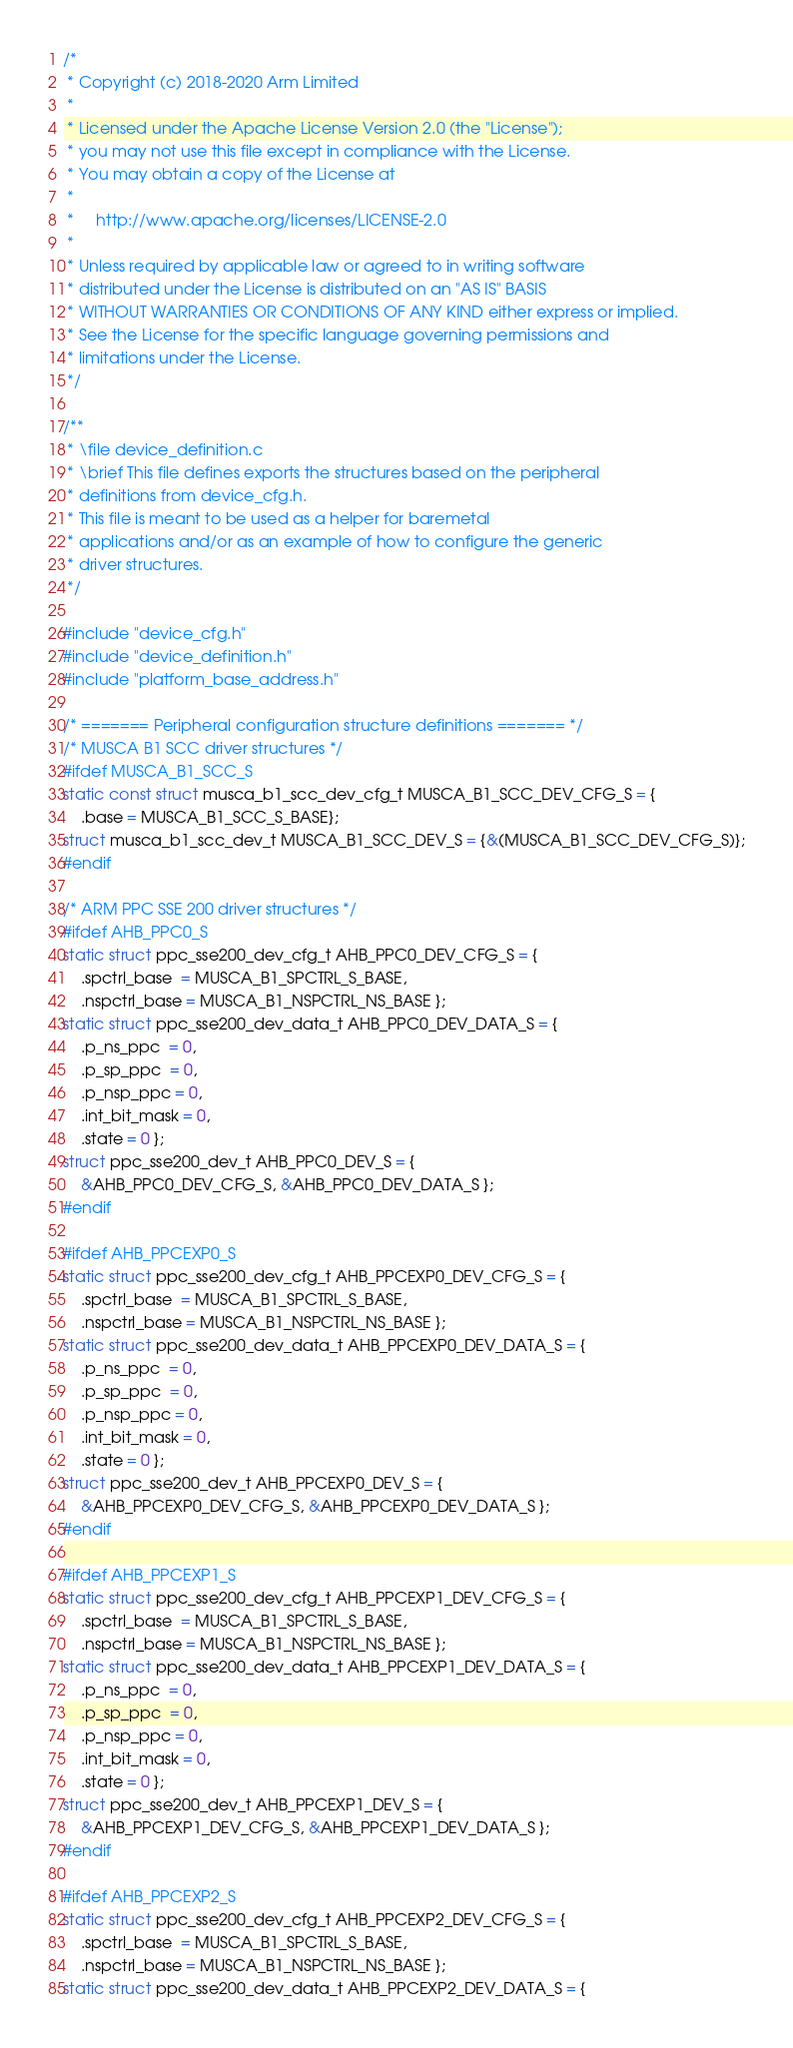<code> <loc_0><loc_0><loc_500><loc_500><_C_>/*
 * Copyright (c) 2018-2020 Arm Limited
 *
 * Licensed under the Apache License Version 2.0 (the "License");
 * you may not use this file except in compliance with the License.
 * You may obtain a copy of the License at
 *
 *     http://www.apache.org/licenses/LICENSE-2.0
 *
 * Unless required by applicable law or agreed to in writing software
 * distributed under the License is distributed on an "AS IS" BASIS
 * WITHOUT WARRANTIES OR CONDITIONS OF ANY KIND either express or implied.
 * See the License for the specific language governing permissions and
 * limitations under the License.
 */

/**
 * \file device_definition.c
 * \brief This file defines exports the structures based on the peripheral
 * definitions from device_cfg.h.
 * This file is meant to be used as a helper for baremetal
 * applications and/or as an example of how to configure the generic
 * driver structures.
 */

#include "device_cfg.h"
#include "device_definition.h"
#include "platform_base_address.h"

/* ======= Peripheral configuration structure definitions ======= */
/* MUSCA B1 SCC driver structures */
#ifdef MUSCA_B1_SCC_S
static const struct musca_b1_scc_dev_cfg_t MUSCA_B1_SCC_DEV_CFG_S = {
    .base = MUSCA_B1_SCC_S_BASE};
struct musca_b1_scc_dev_t MUSCA_B1_SCC_DEV_S = {&(MUSCA_B1_SCC_DEV_CFG_S)};
#endif

/* ARM PPC SSE 200 driver structures */
#ifdef AHB_PPC0_S
static struct ppc_sse200_dev_cfg_t AHB_PPC0_DEV_CFG_S = {
    .spctrl_base  = MUSCA_B1_SPCTRL_S_BASE,
    .nspctrl_base = MUSCA_B1_NSPCTRL_NS_BASE };
static struct ppc_sse200_dev_data_t AHB_PPC0_DEV_DATA_S = {
    .p_ns_ppc  = 0,
    .p_sp_ppc  = 0,
    .p_nsp_ppc = 0,
    .int_bit_mask = 0,
    .state = 0 };
struct ppc_sse200_dev_t AHB_PPC0_DEV_S = {
    &AHB_PPC0_DEV_CFG_S, &AHB_PPC0_DEV_DATA_S };
#endif

#ifdef AHB_PPCEXP0_S
static struct ppc_sse200_dev_cfg_t AHB_PPCEXP0_DEV_CFG_S = {
    .spctrl_base  = MUSCA_B1_SPCTRL_S_BASE,
    .nspctrl_base = MUSCA_B1_NSPCTRL_NS_BASE };
static struct ppc_sse200_dev_data_t AHB_PPCEXP0_DEV_DATA_S = {
    .p_ns_ppc  = 0,
    .p_sp_ppc  = 0,
    .p_nsp_ppc = 0,
    .int_bit_mask = 0,
    .state = 0 };
struct ppc_sse200_dev_t AHB_PPCEXP0_DEV_S = {
    &AHB_PPCEXP0_DEV_CFG_S, &AHB_PPCEXP0_DEV_DATA_S };
#endif

#ifdef AHB_PPCEXP1_S
static struct ppc_sse200_dev_cfg_t AHB_PPCEXP1_DEV_CFG_S = {
    .spctrl_base  = MUSCA_B1_SPCTRL_S_BASE,
    .nspctrl_base = MUSCA_B1_NSPCTRL_NS_BASE };
static struct ppc_sse200_dev_data_t AHB_PPCEXP1_DEV_DATA_S = {
    .p_ns_ppc  = 0,
    .p_sp_ppc  = 0,
    .p_nsp_ppc = 0,
    .int_bit_mask = 0,
    .state = 0 };
struct ppc_sse200_dev_t AHB_PPCEXP1_DEV_S = {
    &AHB_PPCEXP1_DEV_CFG_S, &AHB_PPCEXP1_DEV_DATA_S };
#endif

#ifdef AHB_PPCEXP2_S
static struct ppc_sse200_dev_cfg_t AHB_PPCEXP2_DEV_CFG_S = {
    .spctrl_base  = MUSCA_B1_SPCTRL_S_BASE,
    .nspctrl_base = MUSCA_B1_NSPCTRL_NS_BASE };
static struct ppc_sse200_dev_data_t AHB_PPCEXP2_DEV_DATA_S = {</code> 